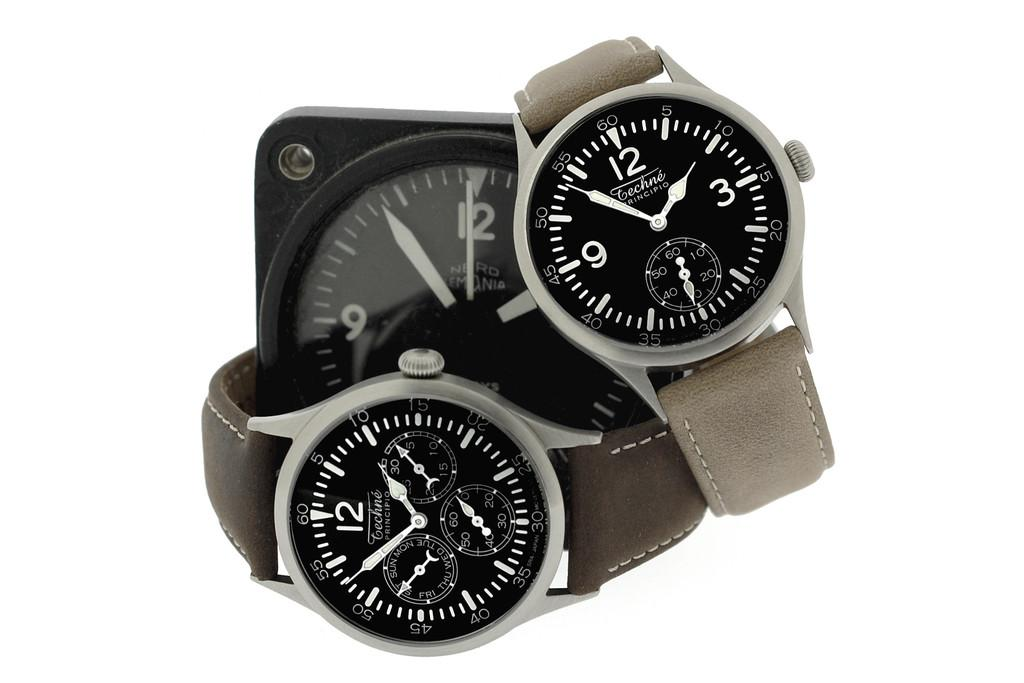Provide a one-sentence caption for the provided image. Two Technie watches are placed around a desk clock. 